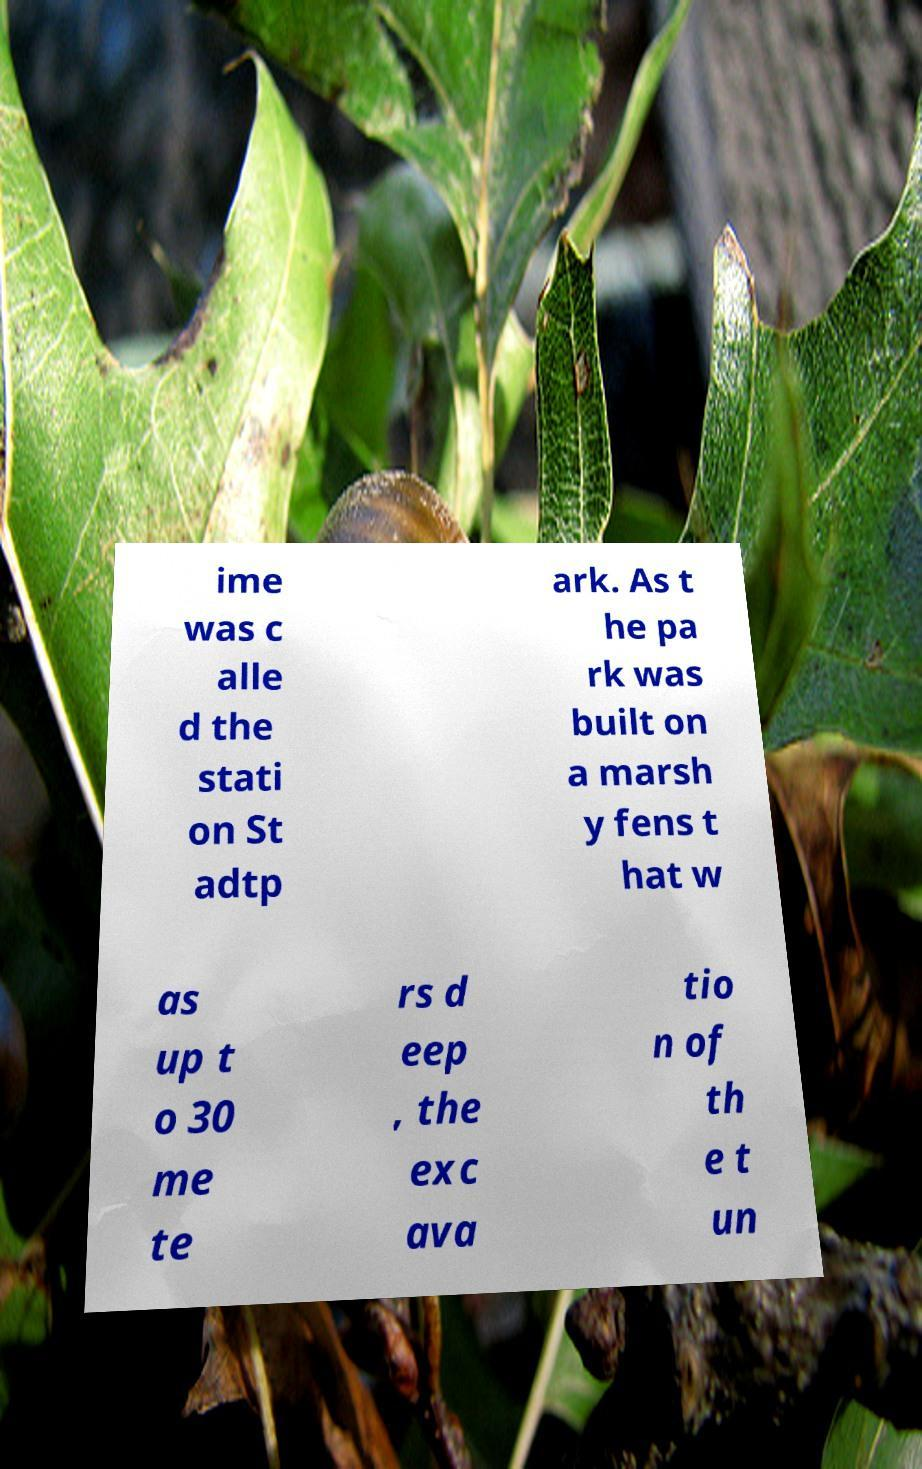I need the written content from this picture converted into text. Can you do that? ime was c alle d the stati on St adtp ark. As t he pa rk was built on a marsh y fens t hat w as up t o 30 me te rs d eep , the exc ava tio n of th e t un 